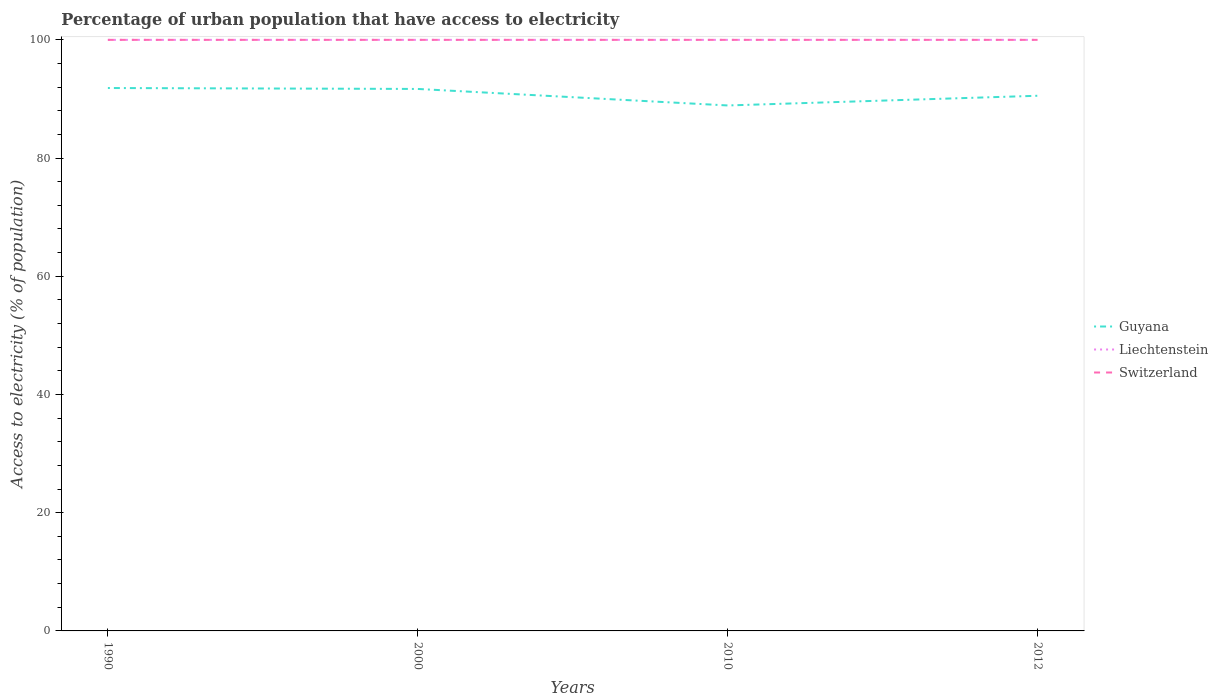How many different coloured lines are there?
Your response must be concise. 3. Across all years, what is the maximum percentage of urban population that have access to electricity in Guyana?
Provide a succinct answer. 88.9. What is the difference between the highest and the second highest percentage of urban population that have access to electricity in Switzerland?
Give a very brief answer. 0. What is the difference between the highest and the lowest percentage of urban population that have access to electricity in Liechtenstein?
Your answer should be compact. 0. How many lines are there?
Give a very brief answer. 3. How many years are there in the graph?
Ensure brevity in your answer.  4. Does the graph contain any zero values?
Make the answer very short. No. Does the graph contain grids?
Your response must be concise. No. How many legend labels are there?
Your response must be concise. 3. What is the title of the graph?
Ensure brevity in your answer.  Percentage of urban population that have access to electricity. What is the label or title of the Y-axis?
Your answer should be very brief. Access to electricity (% of population). What is the Access to electricity (% of population) in Guyana in 1990?
Make the answer very short. 91.85. What is the Access to electricity (% of population) in Switzerland in 1990?
Offer a very short reply. 100. What is the Access to electricity (% of population) in Guyana in 2000?
Make the answer very short. 91.69. What is the Access to electricity (% of population) of Guyana in 2010?
Make the answer very short. 88.9. What is the Access to electricity (% of population) of Guyana in 2012?
Ensure brevity in your answer.  90.54. What is the Access to electricity (% of population) in Liechtenstein in 2012?
Make the answer very short. 100. Across all years, what is the maximum Access to electricity (% of population) of Guyana?
Keep it short and to the point. 91.85. Across all years, what is the maximum Access to electricity (% of population) in Liechtenstein?
Give a very brief answer. 100. Across all years, what is the minimum Access to electricity (% of population) in Guyana?
Provide a short and direct response. 88.9. Across all years, what is the minimum Access to electricity (% of population) in Switzerland?
Make the answer very short. 100. What is the total Access to electricity (% of population) in Guyana in the graph?
Give a very brief answer. 362.99. What is the total Access to electricity (% of population) in Switzerland in the graph?
Provide a short and direct response. 400. What is the difference between the Access to electricity (% of population) in Guyana in 1990 and that in 2000?
Give a very brief answer. 0.16. What is the difference between the Access to electricity (% of population) of Liechtenstein in 1990 and that in 2000?
Give a very brief answer. 0. What is the difference between the Access to electricity (% of population) of Guyana in 1990 and that in 2010?
Provide a short and direct response. 2.95. What is the difference between the Access to electricity (% of population) in Liechtenstein in 1990 and that in 2010?
Make the answer very short. 0. What is the difference between the Access to electricity (% of population) in Switzerland in 1990 and that in 2010?
Make the answer very short. 0. What is the difference between the Access to electricity (% of population) of Guyana in 1990 and that in 2012?
Provide a short and direct response. 1.31. What is the difference between the Access to electricity (% of population) of Liechtenstein in 1990 and that in 2012?
Keep it short and to the point. 0. What is the difference between the Access to electricity (% of population) of Switzerland in 1990 and that in 2012?
Provide a succinct answer. 0. What is the difference between the Access to electricity (% of population) of Guyana in 2000 and that in 2010?
Provide a succinct answer. 2.79. What is the difference between the Access to electricity (% of population) in Liechtenstein in 2000 and that in 2010?
Offer a terse response. 0. What is the difference between the Access to electricity (% of population) of Switzerland in 2000 and that in 2010?
Your response must be concise. 0. What is the difference between the Access to electricity (% of population) of Guyana in 2000 and that in 2012?
Keep it short and to the point. 1.15. What is the difference between the Access to electricity (% of population) of Switzerland in 2000 and that in 2012?
Offer a terse response. 0. What is the difference between the Access to electricity (% of population) in Guyana in 2010 and that in 2012?
Make the answer very short. -1.64. What is the difference between the Access to electricity (% of population) in Liechtenstein in 2010 and that in 2012?
Your response must be concise. 0. What is the difference between the Access to electricity (% of population) in Switzerland in 2010 and that in 2012?
Give a very brief answer. 0. What is the difference between the Access to electricity (% of population) in Guyana in 1990 and the Access to electricity (% of population) in Liechtenstein in 2000?
Your response must be concise. -8.15. What is the difference between the Access to electricity (% of population) of Guyana in 1990 and the Access to electricity (% of population) of Switzerland in 2000?
Offer a terse response. -8.15. What is the difference between the Access to electricity (% of population) of Liechtenstein in 1990 and the Access to electricity (% of population) of Switzerland in 2000?
Offer a very short reply. 0. What is the difference between the Access to electricity (% of population) in Guyana in 1990 and the Access to electricity (% of population) in Liechtenstein in 2010?
Provide a short and direct response. -8.15. What is the difference between the Access to electricity (% of population) of Guyana in 1990 and the Access to electricity (% of population) of Switzerland in 2010?
Your answer should be very brief. -8.15. What is the difference between the Access to electricity (% of population) of Guyana in 1990 and the Access to electricity (% of population) of Liechtenstein in 2012?
Offer a very short reply. -8.15. What is the difference between the Access to electricity (% of population) in Guyana in 1990 and the Access to electricity (% of population) in Switzerland in 2012?
Make the answer very short. -8.15. What is the difference between the Access to electricity (% of population) of Guyana in 2000 and the Access to electricity (% of population) of Liechtenstein in 2010?
Give a very brief answer. -8.31. What is the difference between the Access to electricity (% of population) in Guyana in 2000 and the Access to electricity (% of population) in Switzerland in 2010?
Keep it short and to the point. -8.31. What is the difference between the Access to electricity (% of population) of Liechtenstein in 2000 and the Access to electricity (% of population) of Switzerland in 2010?
Offer a terse response. 0. What is the difference between the Access to electricity (% of population) of Guyana in 2000 and the Access to electricity (% of population) of Liechtenstein in 2012?
Provide a succinct answer. -8.31. What is the difference between the Access to electricity (% of population) in Guyana in 2000 and the Access to electricity (% of population) in Switzerland in 2012?
Your answer should be very brief. -8.31. What is the difference between the Access to electricity (% of population) in Guyana in 2010 and the Access to electricity (% of population) in Liechtenstein in 2012?
Your response must be concise. -11.1. What is the difference between the Access to electricity (% of population) in Guyana in 2010 and the Access to electricity (% of population) in Switzerland in 2012?
Ensure brevity in your answer.  -11.1. What is the average Access to electricity (% of population) in Guyana per year?
Offer a terse response. 90.75. In the year 1990, what is the difference between the Access to electricity (% of population) in Guyana and Access to electricity (% of population) in Liechtenstein?
Provide a succinct answer. -8.15. In the year 1990, what is the difference between the Access to electricity (% of population) in Guyana and Access to electricity (% of population) in Switzerland?
Keep it short and to the point. -8.15. In the year 2000, what is the difference between the Access to electricity (% of population) of Guyana and Access to electricity (% of population) of Liechtenstein?
Give a very brief answer. -8.31. In the year 2000, what is the difference between the Access to electricity (% of population) in Guyana and Access to electricity (% of population) in Switzerland?
Make the answer very short. -8.31. In the year 2010, what is the difference between the Access to electricity (% of population) in Guyana and Access to electricity (% of population) in Liechtenstein?
Offer a very short reply. -11.1. In the year 2010, what is the difference between the Access to electricity (% of population) in Guyana and Access to electricity (% of population) in Switzerland?
Your answer should be very brief. -11.1. In the year 2010, what is the difference between the Access to electricity (% of population) in Liechtenstein and Access to electricity (% of population) in Switzerland?
Your answer should be compact. 0. In the year 2012, what is the difference between the Access to electricity (% of population) of Guyana and Access to electricity (% of population) of Liechtenstein?
Offer a terse response. -9.46. In the year 2012, what is the difference between the Access to electricity (% of population) of Guyana and Access to electricity (% of population) of Switzerland?
Make the answer very short. -9.46. What is the ratio of the Access to electricity (% of population) of Guyana in 1990 to that in 2000?
Provide a short and direct response. 1. What is the ratio of the Access to electricity (% of population) in Liechtenstein in 1990 to that in 2000?
Your answer should be compact. 1. What is the ratio of the Access to electricity (% of population) in Switzerland in 1990 to that in 2000?
Keep it short and to the point. 1. What is the ratio of the Access to electricity (% of population) of Guyana in 1990 to that in 2010?
Offer a very short reply. 1.03. What is the ratio of the Access to electricity (% of population) of Liechtenstein in 1990 to that in 2010?
Your response must be concise. 1. What is the ratio of the Access to electricity (% of population) of Switzerland in 1990 to that in 2010?
Offer a terse response. 1. What is the ratio of the Access to electricity (% of population) of Guyana in 1990 to that in 2012?
Keep it short and to the point. 1.01. What is the ratio of the Access to electricity (% of population) in Liechtenstein in 1990 to that in 2012?
Make the answer very short. 1. What is the ratio of the Access to electricity (% of population) of Guyana in 2000 to that in 2010?
Give a very brief answer. 1.03. What is the ratio of the Access to electricity (% of population) in Liechtenstein in 2000 to that in 2010?
Provide a succinct answer. 1. What is the ratio of the Access to electricity (% of population) in Switzerland in 2000 to that in 2010?
Your answer should be very brief. 1. What is the ratio of the Access to electricity (% of population) in Guyana in 2000 to that in 2012?
Give a very brief answer. 1.01. What is the ratio of the Access to electricity (% of population) of Liechtenstein in 2000 to that in 2012?
Ensure brevity in your answer.  1. What is the ratio of the Access to electricity (% of population) in Switzerland in 2000 to that in 2012?
Provide a short and direct response. 1. What is the ratio of the Access to electricity (% of population) in Guyana in 2010 to that in 2012?
Make the answer very short. 0.98. What is the difference between the highest and the second highest Access to electricity (% of population) in Guyana?
Your response must be concise. 0.16. What is the difference between the highest and the second highest Access to electricity (% of population) of Liechtenstein?
Offer a very short reply. 0. What is the difference between the highest and the lowest Access to electricity (% of population) in Guyana?
Ensure brevity in your answer.  2.95. What is the difference between the highest and the lowest Access to electricity (% of population) of Switzerland?
Ensure brevity in your answer.  0. 